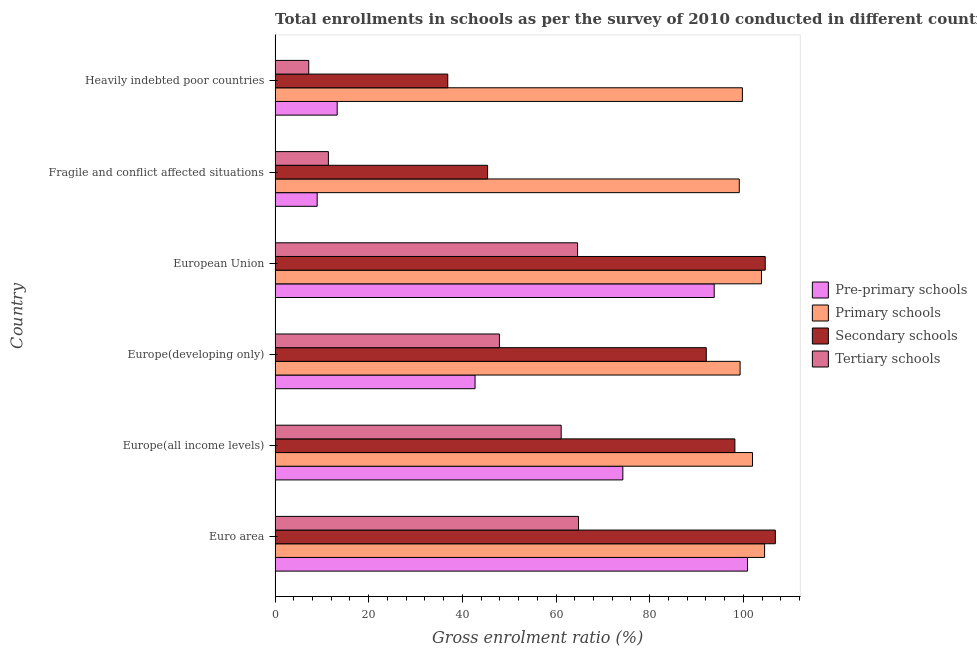How many groups of bars are there?
Your response must be concise. 6. What is the label of the 4th group of bars from the top?
Offer a very short reply. Europe(developing only). What is the gross enrolment ratio in pre-primary schools in European Union?
Make the answer very short. 93.79. Across all countries, what is the maximum gross enrolment ratio in secondary schools?
Provide a succinct answer. 106.85. Across all countries, what is the minimum gross enrolment ratio in pre-primary schools?
Offer a very short reply. 8.99. In which country was the gross enrolment ratio in tertiary schools maximum?
Provide a short and direct response. Euro area. In which country was the gross enrolment ratio in pre-primary schools minimum?
Your response must be concise. Fragile and conflict affected situations. What is the total gross enrolment ratio in primary schools in the graph?
Make the answer very short. 608.69. What is the difference between the gross enrolment ratio in pre-primary schools in Europe(all income levels) and that in European Union?
Make the answer very short. -19.51. What is the difference between the gross enrolment ratio in tertiary schools in Europe(all income levels) and the gross enrolment ratio in secondary schools in European Union?
Ensure brevity in your answer.  -43.58. What is the average gross enrolment ratio in tertiary schools per country?
Your answer should be compact. 42.84. What is the difference between the gross enrolment ratio in secondary schools and gross enrolment ratio in primary schools in European Union?
Keep it short and to the point. 0.8. In how many countries, is the gross enrolment ratio in secondary schools greater than 80 %?
Your answer should be very brief. 4. What is the ratio of the gross enrolment ratio in secondary schools in Europe(all income levels) to that in Fragile and conflict affected situations?
Offer a very short reply. 2.16. What is the difference between the highest and the second highest gross enrolment ratio in pre-primary schools?
Give a very brief answer. 7.12. What is the difference between the highest and the lowest gross enrolment ratio in tertiary schools?
Keep it short and to the point. 57.61. In how many countries, is the gross enrolment ratio in primary schools greater than the average gross enrolment ratio in primary schools taken over all countries?
Your answer should be compact. 3. Is the sum of the gross enrolment ratio in primary schools in Europe(developing only) and Fragile and conflict affected situations greater than the maximum gross enrolment ratio in secondary schools across all countries?
Offer a terse response. Yes. Is it the case that in every country, the sum of the gross enrolment ratio in pre-primary schools and gross enrolment ratio in secondary schools is greater than the sum of gross enrolment ratio in tertiary schools and gross enrolment ratio in primary schools?
Provide a short and direct response. No. What does the 1st bar from the top in Europe(all income levels) represents?
Your answer should be compact. Tertiary schools. What does the 3rd bar from the bottom in Europe(all income levels) represents?
Make the answer very short. Secondary schools. How many bars are there?
Give a very brief answer. 24. How many countries are there in the graph?
Your answer should be compact. 6. Does the graph contain any zero values?
Your answer should be compact. No. Does the graph contain grids?
Provide a short and direct response. No. How many legend labels are there?
Ensure brevity in your answer.  4. How are the legend labels stacked?
Ensure brevity in your answer.  Vertical. What is the title of the graph?
Give a very brief answer. Total enrollments in schools as per the survey of 2010 conducted in different countries. Does "Plant species" appear as one of the legend labels in the graph?
Provide a succinct answer. No. What is the label or title of the X-axis?
Your answer should be very brief. Gross enrolment ratio (%). What is the label or title of the Y-axis?
Provide a succinct answer. Country. What is the Gross enrolment ratio (%) in Pre-primary schools in Euro area?
Your answer should be very brief. 100.91. What is the Gross enrolment ratio (%) of Primary schools in Euro area?
Your answer should be compact. 104.55. What is the Gross enrolment ratio (%) in Secondary schools in Euro area?
Offer a very short reply. 106.85. What is the Gross enrolment ratio (%) of Tertiary schools in Euro area?
Keep it short and to the point. 64.81. What is the Gross enrolment ratio (%) in Pre-primary schools in Europe(all income levels)?
Your response must be concise. 74.28. What is the Gross enrolment ratio (%) of Primary schools in Europe(all income levels)?
Offer a terse response. 101.97. What is the Gross enrolment ratio (%) of Secondary schools in Europe(all income levels)?
Provide a succinct answer. 98.21. What is the Gross enrolment ratio (%) of Tertiary schools in Europe(all income levels)?
Provide a succinct answer. 61.11. What is the Gross enrolment ratio (%) of Pre-primary schools in Europe(developing only)?
Your answer should be compact. 42.71. What is the Gross enrolment ratio (%) of Primary schools in Europe(developing only)?
Offer a very short reply. 99.32. What is the Gross enrolment ratio (%) in Secondary schools in Europe(developing only)?
Your answer should be very brief. 92.1. What is the Gross enrolment ratio (%) of Tertiary schools in Europe(developing only)?
Offer a very short reply. 47.91. What is the Gross enrolment ratio (%) of Pre-primary schools in European Union?
Provide a short and direct response. 93.79. What is the Gross enrolment ratio (%) in Primary schools in European Union?
Your answer should be compact. 103.89. What is the Gross enrolment ratio (%) in Secondary schools in European Union?
Give a very brief answer. 104.69. What is the Gross enrolment ratio (%) of Tertiary schools in European Union?
Provide a short and direct response. 64.61. What is the Gross enrolment ratio (%) in Pre-primary schools in Fragile and conflict affected situations?
Offer a terse response. 8.99. What is the Gross enrolment ratio (%) in Primary schools in Fragile and conflict affected situations?
Provide a short and direct response. 99.14. What is the Gross enrolment ratio (%) in Secondary schools in Fragile and conflict affected situations?
Provide a succinct answer. 45.39. What is the Gross enrolment ratio (%) in Tertiary schools in Fragile and conflict affected situations?
Give a very brief answer. 11.39. What is the Gross enrolment ratio (%) of Pre-primary schools in Heavily indebted poor countries?
Offer a terse response. 13.27. What is the Gross enrolment ratio (%) of Primary schools in Heavily indebted poor countries?
Provide a succinct answer. 99.81. What is the Gross enrolment ratio (%) in Secondary schools in Heavily indebted poor countries?
Provide a short and direct response. 36.88. What is the Gross enrolment ratio (%) in Tertiary schools in Heavily indebted poor countries?
Your answer should be compact. 7.19. Across all countries, what is the maximum Gross enrolment ratio (%) of Pre-primary schools?
Offer a very short reply. 100.91. Across all countries, what is the maximum Gross enrolment ratio (%) of Primary schools?
Your answer should be compact. 104.55. Across all countries, what is the maximum Gross enrolment ratio (%) of Secondary schools?
Ensure brevity in your answer.  106.85. Across all countries, what is the maximum Gross enrolment ratio (%) of Tertiary schools?
Offer a very short reply. 64.81. Across all countries, what is the minimum Gross enrolment ratio (%) in Pre-primary schools?
Your answer should be very brief. 8.99. Across all countries, what is the minimum Gross enrolment ratio (%) of Primary schools?
Make the answer very short. 99.14. Across all countries, what is the minimum Gross enrolment ratio (%) of Secondary schools?
Provide a short and direct response. 36.88. Across all countries, what is the minimum Gross enrolment ratio (%) in Tertiary schools?
Your answer should be compact. 7.19. What is the total Gross enrolment ratio (%) of Pre-primary schools in the graph?
Keep it short and to the point. 333.94. What is the total Gross enrolment ratio (%) of Primary schools in the graph?
Ensure brevity in your answer.  608.69. What is the total Gross enrolment ratio (%) in Secondary schools in the graph?
Give a very brief answer. 484.12. What is the total Gross enrolment ratio (%) of Tertiary schools in the graph?
Provide a succinct answer. 257.01. What is the difference between the Gross enrolment ratio (%) in Pre-primary schools in Euro area and that in Europe(all income levels)?
Provide a succinct answer. 26.63. What is the difference between the Gross enrolment ratio (%) of Primary schools in Euro area and that in Europe(all income levels)?
Ensure brevity in your answer.  2.58. What is the difference between the Gross enrolment ratio (%) of Secondary schools in Euro area and that in Europe(all income levels)?
Your response must be concise. 8.64. What is the difference between the Gross enrolment ratio (%) of Tertiary schools in Euro area and that in Europe(all income levels)?
Make the answer very short. 3.7. What is the difference between the Gross enrolment ratio (%) in Pre-primary schools in Euro area and that in Europe(developing only)?
Give a very brief answer. 58.19. What is the difference between the Gross enrolment ratio (%) of Primary schools in Euro area and that in Europe(developing only)?
Your answer should be very brief. 5.23. What is the difference between the Gross enrolment ratio (%) of Secondary schools in Euro area and that in Europe(developing only)?
Make the answer very short. 14.75. What is the difference between the Gross enrolment ratio (%) in Tertiary schools in Euro area and that in Europe(developing only)?
Your answer should be compact. 16.89. What is the difference between the Gross enrolment ratio (%) of Pre-primary schools in Euro area and that in European Union?
Offer a very short reply. 7.12. What is the difference between the Gross enrolment ratio (%) in Primary schools in Euro area and that in European Union?
Offer a terse response. 0.66. What is the difference between the Gross enrolment ratio (%) of Secondary schools in Euro area and that in European Union?
Offer a terse response. 2.16. What is the difference between the Gross enrolment ratio (%) of Tertiary schools in Euro area and that in European Union?
Provide a succinct answer. 0.2. What is the difference between the Gross enrolment ratio (%) in Pre-primary schools in Euro area and that in Fragile and conflict affected situations?
Provide a succinct answer. 91.92. What is the difference between the Gross enrolment ratio (%) in Primary schools in Euro area and that in Fragile and conflict affected situations?
Your answer should be very brief. 5.41. What is the difference between the Gross enrolment ratio (%) in Secondary schools in Euro area and that in Fragile and conflict affected situations?
Offer a very short reply. 61.46. What is the difference between the Gross enrolment ratio (%) in Tertiary schools in Euro area and that in Fragile and conflict affected situations?
Offer a terse response. 53.42. What is the difference between the Gross enrolment ratio (%) of Pre-primary schools in Euro area and that in Heavily indebted poor countries?
Make the answer very short. 87.64. What is the difference between the Gross enrolment ratio (%) in Primary schools in Euro area and that in Heavily indebted poor countries?
Give a very brief answer. 4.74. What is the difference between the Gross enrolment ratio (%) of Secondary schools in Euro area and that in Heavily indebted poor countries?
Your response must be concise. 69.97. What is the difference between the Gross enrolment ratio (%) of Tertiary schools in Euro area and that in Heavily indebted poor countries?
Keep it short and to the point. 57.61. What is the difference between the Gross enrolment ratio (%) in Pre-primary schools in Europe(all income levels) and that in Europe(developing only)?
Provide a short and direct response. 31.56. What is the difference between the Gross enrolment ratio (%) in Primary schools in Europe(all income levels) and that in Europe(developing only)?
Offer a very short reply. 2.65. What is the difference between the Gross enrolment ratio (%) of Secondary schools in Europe(all income levels) and that in Europe(developing only)?
Your answer should be very brief. 6.11. What is the difference between the Gross enrolment ratio (%) of Tertiary schools in Europe(all income levels) and that in Europe(developing only)?
Your answer should be compact. 13.19. What is the difference between the Gross enrolment ratio (%) in Pre-primary schools in Europe(all income levels) and that in European Union?
Your response must be concise. -19.51. What is the difference between the Gross enrolment ratio (%) in Primary schools in Europe(all income levels) and that in European Union?
Offer a very short reply. -1.92. What is the difference between the Gross enrolment ratio (%) of Secondary schools in Europe(all income levels) and that in European Union?
Ensure brevity in your answer.  -6.48. What is the difference between the Gross enrolment ratio (%) in Tertiary schools in Europe(all income levels) and that in European Union?
Offer a very short reply. -3.5. What is the difference between the Gross enrolment ratio (%) of Pre-primary schools in Europe(all income levels) and that in Fragile and conflict affected situations?
Provide a succinct answer. 65.29. What is the difference between the Gross enrolment ratio (%) in Primary schools in Europe(all income levels) and that in Fragile and conflict affected situations?
Your response must be concise. 2.83. What is the difference between the Gross enrolment ratio (%) of Secondary schools in Europe(all income levels) and that in Fragile and conflict affected situations?
Provide a short and direct response. 52.82. What is the difference between the Gross enrolment ratio (%) of Tertiary schools in Europe(all income levels) and that in Fragile and conflict affected situations?
Your answer should be compact. 49.72. What is the difference between the Gross enrolment ratio (%) of Pre-primary schools in Europe(all income levels) and that in Heavily indebted poor countries?
Keep it short and to the point. 61.01. What is the difference between the Gross enrolment ratio (%) of Primary schools in Europe(all income levels) and that in Heavily indebted poor countries?
Your answer should be compact. 2.16. What is the difference between the Gross enrolment ratio (%) of Secondary schools in Europe(all income levels) and that in Heavily indebted poor countries?
Offer a very short reply. 61.33. What is the difference between the Gross enrolment ratio (%) of Tertiary schools in Europe(all income levels) and that in Heavily indebted poor countries?
Provide a short and direct response. 53.92. What is the difference between the Gross enrolment ratio (%) in Pre-primary schools in Europe(developing only) and that in European Union?
Give a very brief answer. -51.08. What is the difference between the Gross enrolment ratio (%) of Primary schools in Europe(developing only) and that in European Union?
Give a very brief answer. -4.57. What is the difference between the Gross enrolment ratio (%) of Secondary schools in Europe(developing only) and that in European Union?
Give a very brief answer. -12.59. What is the difference between the Gross enrolment ratio (%) in Tertiary schools in Europe(developing only) and that in European Union?
Provide a short and direct response. -16.69. What is the difference between the Gross enrolment ratio (%) of Pre-primary schools in Europe(developing only) and that in Fragile and conflict affected situations?
Offer a very short reply. 33.72. What is the difference between the Gross enrolment ratio (%) in Primary schools in Europe(developing only) and that in Fragile and conflict affected situations?
Ensure brevity in your answer.  0.18. What is the difference between the Gross enrolment ratio (%) of Secondary schools in Europe(developing only) and that in Fragile and conflict affected situations?
Offer a very short reply. 46.71. What is the difference between the Gross enrolment ratio (%) in Tertiary schools in Europe(developing only) and that in Fragile and conflict affected situations?
Your answer should be compact. 36.53. What is the difference between the Gross enrolment ratio (%) of Pre-primary schools in Europe(developing only) and that in Heavily indebted poor countries?
Offer a very short reply. 29.45. What is the difference between the Gross enrolment ratio (%) in Primary schools in Europe(developing only) and that in Heavily indebted poor countries?
Make the answer very short. -0.49. What is the difference between the Gross enrolment ratio (%) in Secondary schools in Europe(developing only) and that in Heavily indebted poor countries?
Your response must be concise. 55.22. What is the difference between the Gross enrolment ratio (%) in Tertiary schools in Europe(developing only) and that in Heavily indebted poor countries?
Offer a very short reply. 40.72. What is the difference between the Gross enrolment ratio (%) of Pre-primary schools in European Union and that in Fragile and conflict affected situations?
Provide a succinct answer. 84.8. What is the difference between the Gross enrolment ratio (%) of Primary schools in European Union and that in Fragile and conflict affected situations?
Ensure brevity in your answer.  4.75. What is the difference between the Gross enrolment ratio (%) of Secondary schools in European Union and that in Fragile and conflict affected situations?
Keep it short and to the point. 59.3. What is the difference between the Gross enrolment ratio (%) in Tertiary schools in European Union and that in Fragile and conflict affected situations?
Your answer should be very brief. 53.22. What is the difference between the Gross enrolment ratio (%) in Pre-primary schools in European Union and that in Heavily indebted poor countries?
Provide a short and direct response. 80.52. What is the difference between the Gross enrolment ratio (%) in Primary schools in European Union and that in Heavily indebted poor countries?
Your response must be concise. 4.08. What is the difference between the Gross enrolment ratio (%) in Secondary schools in European Union and that in Heavily indebted poor countries?
Provide a short and direct response. 67.81. What is the difference between the Gross enrolment ratio (%) in Tertiary schools in European Union and that in Heavily indebted poor countries?
Keep it short and to the point. 57.42. What is the difference between the Gross enrolment ratio (%) in Pre-primary schools in Fragile and conflict affected situations and that in Heavily indebted poor countries?
Your answer should be very brief. -4.28. What is the difference between the Gross enrolment ratio (%) of Primary schools in Fragile and conflict affected situations and that in Heavily indebted poor countries?
Ensure brevity in your answer.  -0.67. What is the difference between the Gross enrolment ratio (%) in Secondary schools in Fragile and conflict affected situations and that in Heavily indebted poor countries?
Your answer should be very brief. 8.51. What is the difference between the Gross enrolment ratio (%) in Tertiary schools in Fragile and conflict affected situations and that in Heavily indebted poor countries?
Offer a very short reply. 4.19. What is the difference between the Gross enrolment ratio (%) in Pre-primary schools in Euro area and the Gross enrolment ratio (%) in Primary schools in Europe(all income levels)?
Offer a terse response. -1.06. What is the difference between the Gross enrolment ratio (%) in Pre-primary schools in Euro area and the Gross enrolment ratio (%) in Secondary schools in Europe(all income levels)?
Ensure brevity in your answer.  2.7. What is the difference between the Gross enrolment ratio (%) of Pre-primary schools in Euro area and the Gross enrolment ratio (%) of Tertiary schools in Europe(all income levels)?
Give a very brief answer. 39.8. What is the difference between the Gross enrolment ratio (%) of Primary schools in Euro area and the Gross enrolment ratio (%) of Secondary schools in Europe(all income levels)?
Keep it short and to the point. 6.34. What is the difference between the Gross enrolment ratio (%) in Primary schools in Euro area and the Gross enrolment ratio (%) in Tertiary schools in Europe(all income levels)?
Provide a succinct answer. 43.45. What is the difference between the Gross enrolment ratio (%) of Secondary schools in Euro area and the Gross enrolment ratio (%) of Tertiary schools in Europe(all income levels)?
Offer a very short reply. 45.74. What is the difference between the Gross enrolment ratio (%) in Pre-primary schools in Euro area and the Gross enrolment ratio (%) in Primary schools in Europe(developing only)?
Your response must be concise. 1.59. What is the difference between the Gross enrolment ratio (%) in Pre-primary schools in Euro area and the Gross enrolment ratio (%) in Secondary schools in Europe(developing only)?
Offer a terse response. 8.81. What is the difference between the Gross enrolment ratio (%) of Pre-primary schools in Euro area and the Gross enrolment ratio (%) of Tertiary schools in Europe(developing only)?
Ensure brevity in your answer.  52.99. What is the difference between the Gross enrolment ratio (%) in Primary schools in Euro area and the Gross enrolment ratio (%) in Secondary schools in Europe(developing only)?
Your answer should be compact. 12.45. What is the difference between the Gross enrolment ratio (%) in Primary schools in Euro area and the Gross enrolment ratio (%) in Tertiary schools in Europe(developing only)?
Your answer should be compact. 56.64. What is the difference between the Gross enrolment ratio (%) of Secondary schools in Euro area and the Gross enrolment ratio (%) of Tertiary schools in Europe(developing only)?
Provide a short and direct response. 58.93. What is the difference between the Gross enrolment ratio (%) in Pre-primary schools in Euro area and the Gross enrolment ratio (%) in Primary schools in European Union?
Offer a very short reply. -2.98. What is the difference between the Gross enrolment ratio (%) in Pre-primary schools in Euro area and the Gross enrolment ratio (%) in Secondary schools in European Union?
Make the answer very short. -3.78. What is the difference between the Gross enrolment ratio (%) in Pre-primary schools in Euro area and the Gross enrolment ratio (%) in Tertiary schools in European Union?
Offer a terse response. 36.3. What is the difference between the Gross enrolment ratio (%) of Primary schools in Euro area and the Gross enrolment ratio (%) of Secondary schools in European Union?
Make the answer very short. -0.14. What is the difference between the Gross enrolment ratio (%) of Primary schools in Euro area and the Gross enrolment ratio (%) of Tertiary schools in European Union?
Your response must be concise. 39.95. What is the difference between the Gross enrolment ratio (%) in Secondary schools in Euro area and the Gross enrolment ratio (%) in Tertiary schools in European Union?
Your answer should be compact. 42.24. What is the difference between the Gross enrolment ratio (%) in Pre-primary schools in Euro area and the Gross enrolment ratio (%) in Primary schools in Fragile and conflict affected situations?
Keep it short and to the point. 1.76. What is the difference between the Gross enrolment ratio (%) in Pre-primary schools in Euro area and the Gross enrolment ratio (%) in Secondary schools in Fragile and conflict affected situations?
Offer a terse response. 55.52. What is the difference between the Gross enrolment ratio (%) of Pre-primary schools in Euro area and the Gross enrolment ratio (%) of Tertiary schools in Fragile and conflict affected situations?
Your answer should be compact. 89.52. What is the difference between the Gross enrolment ratio (%) of Primary schools in Euro area and the Gross enrolment ratio (%) of Secondary schools in Fragile and conflict affected situations?
Keep it short and to the point. 59.16. What is the difference between the Gross enrolment ratio (%) of Primary schools in Euro area and the Gross enrolment ratio (%) of Tertiary schools in Fragile and conflict affected situations?
Your answer should be compact. 93.17. What is the difference between the Gross enrolment ratio (%) in Secondary schools in Euro area and the Gross enrolment ratio (%) in Tertiary schools in Fragile and conflict affected situations?
Your answer should be compact. 95.46. What is the difference between the Gross enrolment ratio (%) in Pre-primary schools in Euro area and the Gross enrolment ratio (%) in Primary schools in Heavily indebted poor countries?
Ensure brevity in your answer.  1.1. What is the difference between the Gross enrolment ratio (%) of Pre-primary schools in Euro area and the Gross enrolment ratio (%) of Secondary schools in Heavily indebted poor countries?
Provide a succinct answer. 64.02. What is the difference between the Gross enrolment ratio (%) in Pre-primary schools in Euro area and the Gross enrolment ratio (%) in Tertiary schools in Heavily indebted poor countries?
Keep it short and to the point. 93.72. What is the difference between the Gross enrolment ratio (%) in Primary schools in Euro area and the Gross enrolment ratio (%) in Secondary schools in Heavily indebted poor countries?
Make the answer very short. 67.67. What is the difference between the Gross enrolment ratio (%) of Primary schools in Euro area and the Gross enrolment ratio (%) of Tertiary schools in Heavily indebted poor countries?
Offer a terse response. 97.36. What is the difference between the Gross enrolment ratio (%) in Secondary schools in Euro area and the Gross enrolment ratio (%) in Tertiary schools in Heavily indebted poor countries?
Ensure brevity in your answer.  99.66. What is the difference between the Gross enrolment ratio (%) in Pre-primary schools in Europe(all income levels) and the Gross enrolment ratio (%) in Primary schools in Europe(developing only)?
Provide a succinct answer. -25.04. What is the difference between the Gross enrolment ratio (%) of Pre-primary schools in Europe(all income levels) and the Gross enrolment ratio (%) of Secondary schools in Europe(developing only)?
Give a very brief answer. -17.82. What is the difference between the Gross enrolment ratio (%) of Pre-primary schools in Europe(all income levels) and the Gross enrolment ratio (%) of Tertiary schools in Europe(developing only)?
Keep it short and to the point. 26.36. What is the difference between the Gross enrolment ratio (%) of Primary schools in Europe(all income levels) and the Gross enrolment ratio (%) of Secondary schools in Europe(developing only)?
Offer a terse response. 9.87. What is the difference between the Gross enrolment ratio (%) of Primary schools in Europe(all income levels) and the Gross enrolment ratio (%) of Tertiary schools in Europe(developing only)?
Your response must be concise. 54.06. What is the difference between the Gross enrolment ratio (%) in Secondary schools in Europe(all income levels) and the Gross enrolment ratio (%) in Tertiary schools in Europe(developing only)?
Provide a short and direct response. 50.3. What is the difference between the Gross enrolment ratio (%) of Pre-primary schools in Europe(all income levels) and the Gross enrolment ratio (%) of Primary schools in European Union?
Your response must be concise. -29.61. What is the difference between the Gross enrolment ratio (%) in Pre-primary schools in Europe(all income levels) and the Gross enrolment ratio (%) in Secondary schools in European Union?
Offer a terse response. -30.41. What is the difference between the Gross enrolment ratio (%) of Pre-primary schools in Europe(all income levels) and the Gross enrolment ratio (%) of Tertiary schools in European Union?
Give a very brief answer. 9.67. What is the difference between the Gross enrolment ratio (%) of Primary schools in Europe(all income levels) and the Gross enrolment ratio (%) of Secondary schools in European Union?
Provide a succinct answer. -2.72. What is the difference between the Gross enrolment ratio (%) of Primary schools in Europe(all income levels) and the Gross enrolment ratio (%) of Tertiary schools in European Union?
Keep it short and to the point. 37.36. What is the difference between the Gross enrolment ratio (%) of Secondary schools in Europe(all income levels) and the Gross enrolment ratio (%) of Tertiary schools in European Union?
Give a very brief answer. 33.6. What is the difference between the Gross enrolment ratio (%) in Pre-primary schools in Europe(all income levels) and the Gross enrolment ratio (%) in Primary schools in Fragile and conflict affected situations?
Ensure brevity in your answer.  -24.87. What is the difference between the Gross enrolment ratio (%) in Pre-primary schools in Europe(all income levels) and the Gross enrolment ratio (%) in Secondary schools in Fragile and conflict affected situations?
Make the answer very short. 28.89. What is the difference between the Gross enrolment ratio (%) in Pre-primary schools in Europe(all income levels) and the Gross enrolment ratio (%) in Tertiary schools in Fragile and conflict affected situations?
Your response must be concise. 62.89. What is the difference between the Gross enrolment ratio (%) of Primary schools in Europe(all income levels) and the Gross enrolment ratio (%) of Secondary schools in Fragile and conflict affected situations?
Keep it short and to the point. 56.58. What is the difference between the Gross enrolment ratio (%) in Primary schools in Europe(all income levels) and the Gross enrolment ratio (%) in Tertiary schools in Fragile and conflict affected situations?
Your response must be concise. 90.58. What is the difference between the Gross enrolment ratio (%) of Secondary schools in Europe(all income levels) and the Gross enrolment ratio (%) of Tertiary schools in Fragile and conflict affected situations?
Offer a very short reply. 86.82. What is the difference between the Gross enrolment ratio (%) of Pre-primary schools in Europe(all income levels) and the Gross enrolment ratio (%) of Primary schools in Heavily indebted poor countries?
Provide a succinct answer. -25.53. What is the difference between the Gross enrolment ratio (%) of Pre-primary schools in Europe(all income levels) and the Gross enrolment ratio (%) of Secondary schools in Heavily indebted poor countries?
Offer a terse response. 37.39. What is the difference between the Gross enrolment ratio (%) in Pre-primary schools in Europe(all income levels) and the Gross enrolment ratio (%) in Tertiary schools in Heavily indebted poor countries?
Give a very brief answer. 67.08. What is the difference between the Gross enrolment ratio (%) of Primary schools in Europe(all income levels) and the Gross enrolment ratio (%) of Secondary schools in Heavily indebted poor countries?
Your response must be concise. 65.09. What is the difference between the Gross enrolment ratio (%) in Primary schools in Europe(all income levels) and the Gross enrolment ratio (%) in Tertiary schools in Heavily indebted poor countries?
Keep it short and to the point. 94.78. What is the difference between the Gross enrolment ratio (%) in Secondary schools in Europe(all income levels) and the Gross enrolment ratio (%) in Tertiary schools in Heavily indebted poor countries?
Give a very brief answer. 91.02. What is the difference between the Gross enrolment ratio (%) in Pre-primary schools in Europe(developing only) and the Gross enrolment ratio (%) in Primary schools in European Union?
Keep it short and to the point. -61.18. What is the difference between the Gross enrolment ratio (%) in Pre-primary schools in Europe(developing only) and the Gross enrolment ratio (%) in Secondary schools in European Union?
Make the answer very short. -61.98. What is the difference between the Gross enrolment ratio (%) of Pre-primary schools in Europe(developing only) and the Gross enrolment ratio (%) of Tertiary schools in European Union?
Ensure brevity in your answer.  -21.89. What is the difference between the Gross enrolment ratio (%) in Primary schools in Europe(developing only) and the Gross enrolment ratio (%) in Secondary schools in European Union?
Offer a very short reply. -5.37. What is the difference between the Gross enrolment ratio (%) of Primary schools in Europe(developing only) and the Gross enrolment ratio (%) of Tertiary schools in European Union?
Your answer should be compact. 34.71. What is the difference between the Gross enrolment ratio (%) in Secondary schools in Europe(developing only) and the Gross enrolment ratio (%) in Tertiary schools in European Union?
Make the answer very short. 27.49. What is the difference between the Gross enrolment ratio (%) of Pre-primary schools in Europe(developing only) and the Gross enrolment ratio (%) of Primary schools in Fragile and conflict affected situations?
Provide a short and direct response. -56.43. What is the difference between the Gross enrolment ratio (%) in Pre-primary schools in Europe(developing only) and the Gross enrolment ratio (%) in Secondary schools in Fragile and conflict affected situations?
Provide a succinct answer. -2.68. What is the difference between the Gross enrolment ratio (%) of Pre-primary schools in Europe(developing only) and the Gross enrolment ratio (%) of Tertiary schools in Fragile and conflict affected situations?
Offer a terse response. 31.33. What is the difference between the Gross enrolment ratio (%) in Primary schools in Europe(developing only) and the Gross enrolment ratio (%) in Secondary schools in Fragile and conflict affected situations?
Ensure brevity in your answer.  53.93. What is the difference between the Gross enrolment ratio (%) in Primary schools in Europe(developing only) and the Gross enrolment ratio (%) in Tertiary schools in Fragile and conflict affected situations?
Keep it short and to the point. 87.93. What is the difference between the Gross enrolment ratio (%) in Secondary schools in Europe(developing only) and the Gross enrolment ratio (%) in Tertiary schools in Fragile and conflict affected situations?
Make the answer very short. 80.71. What is the difference between the Gross enrolment ratio (%) of Pre-primary schools in Europe(developing only) and the Gross enrolment ratio (%) of Primary schools in Heavily indebted poor countries?
Make the answer very short. -57.1. What is the difference between the Gross enrolment ratio (%) in Pre-primary schools in Europe(developing only) and the Gross enrolment ratio (%) in Secondary schools in Heavily indebted poor countries?
Keep it short and to the point. 5.83. What is the difference between the Gross enrolment ratio (%) of Pre-primary schools in Europe(developing only) and the Gross enrolment ratio (%) of Tertiary schools in Heavily indebted poor countries?
Offer a very short reply. 35.52. What is the difference between the Gross enrolment ratio (%) of Primary schools in Europe(developing only) and the Gross enrolment ratio (%) of Secondary schools in Heavily indebted poor countries?
Keep it short and to the point. 62.44. What is the difference between the Gross enrolment ratio (%) of Primary schools in Europe(developing only) and the Gross enrolment ratio (%) of Tertiary schools in Heavily indebted poor countries?
Your response must be concise. 92.13. What is the difference between the Gross enrolment ratio (%) in Secondary schools in Europe(developing only) and the Gross enrolment ratio (%) in Tertiary schools in Heavily indebted poor countries?
Provide a succinct answer. 84.91. What is the difference between the Gross enrolment ratio (%) in Pre-primary schools in European Union and the Gross enrolment ratio (%) in Primary schools in Fragile and conflict affected situations?
Offer a very short reply. -5.35. What is the difference between the Gross enrolment ratio (%) in Pre-primary schools in European Union and the Gross enrolment ratio (%) in Secondary schools in Fragile and conflict affected situations?
Give a very brief answer. 48.4. What is the difference between the Gross enrolment ratio (%) in Pre-primary schools in European Union and the Gross enrolment ratio (%) in Tertiary schools in Fragile and conflict affected situations?
Provide a succinct answer. 82.4. What is the difference between the Gross enrolment ratio (%) of Primary schools in European Union and the Gross enrolment ratio (%) of Secondary schools in Fragile and conflict affected situations?
Your response must be concise. 58.5. What is the difference between the Gross enrolment ratio (%) in Primary schools in European Union and the Gross enrolment ratio (%) in Tertiary schools in Fragile and conflict affected situations?
Keep it short and to the point. 92.5. What is the difference between the Gross enrolment ratio (%) of Secondary schools in European Union and the Gross enrolment ratio (%) of Tertiary schools in Fragile and conflict affected situations?
Your answer should be very brief. 93.3. What is the difference between the Gross enrolment ratio (%) in Pre-primary schools in European Union and the Gross enrolment ratio (%) in Primary schools in Heavily indebted poor countries?
Offer a terse response. -6.02. What is the difference between the Gross enrolment ratio (%) of Pre-primary schools in European Union and the Gross enrolment ratio (%) of Secondary schools in Heavily indebted poor countries?
Your answer should be compact. 56.91. What is the difference between the Gross enrolment ratio (%) in Pre-primary schools in European Union and the Gross enrolment ratio (%) in Tertiary schools in Heavily indebted poor countries?
Offer a terse response. 86.6. What is the difference between the Gross enrolment ratio (%) in Primary schools in European Union and the Gross enrolment ratio (%) in Secondary schools in Heavily indebted poor countries?
Your answer should be very brief. 67.01. What is the difference between the Gross enrolment ratio (%) in Primary schools in European Union and the Gross enrolment ratio (%) in Tertiary schools in Heavily indebted poor countries?
Offer a very short reply. 96.7. What is the difference between the Gross enrolment ratio (%) in Secondary schools in European Union and the Gross enrolment ratio (%) in Tertiary schools in Heavily indebted poor countries?
Offer a very short reply. 97.5. What is the difference between the Gross enrolment ratio (%) of Pre-primary schools in Fragile and conflict affected situations and the Gross enrolment ratio (%) of Primary schools in Heavily indebted poor countries?
Give a very brief answer. -90.82. What is the difference between the Gross enrolment ratio (%) of Pre-primary schools in Fragile and conflict affected situations and the Gross enrolment ratio (%) of Secondary schools in Heavily indebted poor countries?
Your answer should be compact. -27.89. What is the difference between the Gross enrolment ratio (%) of Pre-primary schools in Fragile and conflict affected situations and the Gross enrolment ratio (%) of Tertiary schools in Heavily indebted poor countries?
Your answer should be very brief. 1.8. What is the difference between the Gross enrolment ratio (%) in Primary schools in Fragile and conflict affected situations and the Gross enrolment ratio (%) in Secondary schools in Heavily indebted poor countries?
Your answer should be compact. 62.26. What is the difference between the Gross enrolment ratio (%) in Primary schools in Fragile and conflict affected situations and the Gross enrolment ratio (%) in Tertiary schools in Heavily indebted poor countries?
Keep it short and to the point. 91.95. What is the difference between the Gross enrolment ratio (%) of Secondary schools in Fragile and conflict affected situations and the Gross enrolment ratio (%) of Tertiary schools in Heavily indebted poor countries?
Keep it short and to the point. 38.2. What is the average Gross enrolment ratio (%) of Pre-primary schools per country?
Your answer should be compact. 55.66. What is the average Gross enrolment ratio (%) in Primary schools per country?
Provide a succinct answer. 101.45. What is the average Gross enrolment ratio (%) of Secondary schools per country?
Give a very brief answer. 80.69. What is the average Gross enrolment ratio (%) of Tertiary schools per country?
Your answer should be very brief. 42.84. What is the difference between the Gross enrolment ratio (%) of Pre-primary schools and Gross enrolment ratio (%) of Primary schools in Euro area?
Your answer should be compact. -3.65. What is the difference between the Gross enrolment ratio (%) of Pre-primary schools and Gross enrolment ratio (%) of Secondary schools in Euro area?
Ensure brevity in your answer.  -5.94. What is the difference between the Gross enrolment ratio (%) of Pre-primary schools and Gross enrolment ratio (%) of Tertiary schools in Euro area?
Provide a succinct answer. 36.1. What is the difference between the Gross enrolment ratio (%) of Primary schools and Gross enrolment ratio (%) of Secondary schools in Euro area?
Provide a succinct answer. -2.29. What is the difference between the Gross enrolment ratio (%) in Primary schools and Gross enrolment ratio (%) in Tertiary schools in Euro area?
Offer a very short reply. 39.75. What is the difference between the Gross enrolment ratio (%) of Secondary schools and Gross enrolment ratio (%) of Tertiary schools in Euro area?
Give a very brief answer. 42.04. What is the difference between the Gross enrolment ratio (%) of Pre-primary schools and Gross enrolment ratio (%) of Primary schools in Europe(all income levels)?
Give a very brief answer. -27.69. What is the difference between the Gross enrolment ratio (%) in Pre-primary schools and Gross enrolment ratio (%) in Secondary schools in Europe(all income levels)?
Your response must be concise. -23.93. What is the difference between the Gross enrolment ratio (%) of Pre-primary schools and Gross enrolment ratio (%) of Tertiary schools in Europe(all income levels)?
Provide a short and direct response. 13.17. What is the difference between the Gross enrolment ratio (%) in Primary schools and Gross enrolment ratio (%) in Secondary schools in Europe(all income levels)?
Offer a terse response. 3.76. What is the difference between the Gross enrolment ratio (%) in Primary schools and Gross enrolment ratio (%) in Tertiary schools in Europe(all income levels)?
Give a very brief answer. 40.86. What is the difference between the Gross enrolment ratio (%) in Secondary schools and Gross enrolment ratio (%) in Tertiary schools in Europe(all income levels)?
Offer a terse response. 37.1. What is the difference between the Gross enrolment ratio (%) in Pre-primary schools and Gross enrolment ratio (%) in Primary schools in Europe(developing only)?
Ensure brevity in your answer.  -56.61. What is the difference between the Gross enrolment ratio (%) in Pre-primary schools and Gross enrolment ratio (%) in Secondary schools in Europe(developing only)?
Provide a succinct answer. -49.39. What is the difference between the Gross enrolment ratio (%) of Pre-primary schools and Gross enrolment ratio (%) of Tertiary schools in Europe(developing only)?
Make the answer very short. -5.2. What is the difference between the Gross enrolment ratio (%) of Primary schools and Gross enrolment ratio (%) of Secondary schools in Europe(developing only)?
Your response must be concise. 7.22. What is the difference between the Gross enrolment ratio (%) of Primary schools and Gross enrolment ratio (%) of Tertiary schools in Europe(developing only)?
Your response must be concise. 51.4. What is the difference between the Gross enrolment ratio (%) in Secondary schools and Gross enrolment ratio (%) in Tertiary schools in Europe(developing only)?
Ensure brevity in your answer.  44.19. What is the difference between the Gross enrolment ratio (%) in Pre-primary schools and Gross enrolment ratio (%) in Primary schools in European Union?
Your answer should be very brief. -10.1. What is the difference between the Gross enrolment ratio (%) in Pre-primary schools and Gross enrolment ratio (%) in Secondary schools in European Union?
Your answer should be very brief. -10.9. What is the difference between the Gross enrolment ratio (%) of Pre-primary schools and Gross enrolment ratio (%) of Tertiary schools in European Union?
Provide a succinct answer. 29.18. What is the difference between the Gross enrolment ratio (%) in Primary schools and Gross enrolment ratio (%) in Secondary schools in European Union?
Offer a terse response. -0.8. What is the difference between the Gross enrolment ratio (%) in Primary schools and Gross enrolment ratio (%) in Tertiary schools in European Union?
Offer a very short reply. 39.28. What is the difference between the Gross enrolment ratio (%) in Secondary schools and Gross enrolment ratio (%) in Tertiary schools in European Union?
Your response must be concise. 40.08. What is the difference between the Gross enrolment ratio (%) of Pre-primary schools and Gross enrolment ratio (%) of Primary schools in Fragile and conflict affected situations?
Give a very brief answer. -90.15. What is the difference between the Gross enrolment ratio (%) in Pre-primary schools and Gross enrolment ratio (%) in Secondary schools in Fragile and conflict affected situations?
Give a very brief answer. -36.4. What is the difference between the Gross enrolment ratio (%) in Pre-primary schools and Gross enrolment ratio (%) in Tertiary schools in Fragile and conflict affected situations?
Provide a succinct answer. -2.4. What is the difference between the Gross enrolment ratio (%) of Primary schools and Gross enrolment ratio (%) of Secondary schools in Fragile and conflict affected situations?
Give a very brief answer. 53.75. What is the difference between the Gross enrolment ratio (%) in Primary schools and Gross enrolment ratio (%) in Tertiary schools in Fragile and conflict affected situations?
Your answer should be very brief. 87.76. What is the difference between the Gross enrolment ratio (%) in Secondary schools and Gross enrolment ratio (%) in Tertiary schools in Fragile and conflict affected situations?
Give a very brief answer. 34. What is the difference between the Gross enrolment ratio (%) in Pre-primary schools and Gross enrolment ratio (%) in Primary schools in Heavily indebted poor countries?
Your response must be concise. -86.54. What is the difference between the Gross enrolment ratio (%) in Pre-primary schools and Gross enrolment ratio (%) in Secondary schools in Heavily indebted poor countries?
Offer a very short reply. -23.62. What is the difference between the Gross enrolment ratio (%) in Pre-primary schools and Gross enrolment ratio (%) in Tertiary schools in Heavily indebted poor countries?
Ensure brevity in your answer.  6.07. What is the difference between the Gross enrolment ratio (%) in Primary schools and Gross enrolment ratio (%) in Secondary schools in Heavily indebted poor countries?
Offer a very short reply. 62.93. What is the difference between the Gross enrolment ratio (%) in Primary schools and Gross enrolment ratio (%) in Tertiary schools in Heavily indebted poor countries?
Keep it short and to the point. 92.62. What is the difference between the Gross enrolment ratio (%) in Secondary schools and Gross enrolment ratio (%) in Tertiary schools in Heavily indebted poor countries?
Make the answer very short. 29.69. What is the ratio of the Gross enrolment ratio (%) of Pre-primary schools in Euro area to that in Europe(all income levels)?
Give a very brief answer. 1.36. What is the ratio of the Gross enrolment ratio (%) of Primary schools in Euro area to that in Europe(all income levels)?
Offer a terse response. 1.03. What is the ratio of the Gross enrolment ratio (%) of Secondary schools in Euro area to that in Europe(all income levels)?
Ensure brevity in your answer.  1.09. What is the ratio of the Gross enrolment ratio (%) in Tertiary schools in Euro area to that in Europe(all income levels)?
Make the answer very short. 1.06. What is the ratio of the Gross enrolment ratio (%) of Pre-primary schools in Euro area to that in Europe(developing only)?
Your answer should be very brief. 2.36. What is the ratio of the Gross enrolment ratio (%) in Primary schools in Euro area to that in Europe(developing only)?
Provide a succinct answer. 1.05. What is the ratio of the Gross enrolment ratio (%) of Secondary schools in Euro area to that in Europe(developing only)?
Give a very brief answer. 1.16. What is the ratio of the Gross enrolment ratio (%) in Tertiary schools in Euro area to that in Europe(developing only)?
Provide a succinct answer. 1.35. What is the ratio of the Gross enrolment ratio (%) of Pre-primary schools in Euro area to that in European Union?
Provide a short and direct response. 1.08. What is the ratio of the Gross enrolment ratio (%) of Primary schools in Euro area to that in European Union?
Keep it short and to the point. 1.01. What is the ratio of the Gross enrolment ratio (%) of Secondary schools in Euro area to that in European Union?
Provide a short and direct response. 1.02. What is the ratio of the Gross enrolment ratio (%) of Pre-primary schools in Euro area to that in Fragile and conflict affected situations?
Keep it short and to the point. 11.22. What is the ratio of the Gross enrolment ratio (%) of Primary schools in Euro area to that in Fragile and conflict affected situations?
Give a very brief answer. 1.05. What is the ratio of the Gross enrolment ratio (%) in Secondary schools in Euro area to that in Fragile and conflict affected situations?
Make the answer very short. 2.35. What is the ratio of the Gross enrolment ratio (%) in Tertiary schools in Euro area to that in Fragile and conflict affected situations?
Ensure brevity in your answer.  5.69. What is the ratio of the Gross enrolment ratio (%) in Pre-primary schools in Euro area to that in Heavily indebted poor countries?
Give a very brief answer. 7.61. What is the ratio of the Gross enrolment ratio (%) in Primary schools in Euro area to that in Heavily indebted poor countries?
Provide a short and direct response. 1.05. What is the ratio of the Gross enrolment ratio (%) in Secondary schools in Euro area to that in Heavily indebted poor countries?
Your answer should be very brief. 2.9. What is the ratio of the Gross enrolment ratio (%) of Tertiary schools in Euro area to that in Heavily indebted poor countries?
Your answer should be compact. 9.01. What is the ratio of the Gross enrolment ratio (%) in Pre-primary schools in Europe(all income levels) to that in Europe(developing only)?
Provide a succinct answer. 1.74. What is the ratio of the Gross enrolment ratio (%) in Primary schools in Europe(all income levels) to that in Europe(developing only)?
Make the answer very short. 1.03. What is the ratio of the Gross enrolment ratio (%) in Secondary schools in Europe(all income levels) to that in Europe(developing only)?
Provide a succinct answer. 1.07. What is the ratio of the Gross enrolment ratio (%) in Tertiary schools in Europe(all income levels) to that in Europe(developing only)?
Make the answer very short. 1.28. What is the ratio of the Gross enrolment ratio (%) in Pre-primary schools in Europe(all income levels) to that in European Union?
Provide a succinct answer. 0.79. What is the ratio of the Gross enrolment ratio (%) of Primary schools in Europe(all income levels) to that in European Union?
Your answer should be very brief. 0.98. What is the ratio of the Gross enrolment ratio (%) in Secondary schools in Europe(all income levels) to that in European Union?
Keep it short and to the point. 0.94. What is the ratio of the Gross enrolment ratio (%) in Tertiary schools in Europe(all income levels) to that in European Union?
Give a very brief answer. 0.95. What is the ratio of the Gross enrolment ratio (%) of Pre-primary schools in Europe(all income levels) to that in Fragile and conflict affected situations?
Offer a terse response. 8.26. What is the ratio of the Gross enrolment ratio (%) in Primary schools in Europe(all income levels) to that in Fragile and conflict affected situations?
Provide a succinct answer. 1.03. What is the ratio of the Gross enrolment ratio (%) of Secondary schools in Europe(all income levels) to that in Fragile and conflict affected situations?
Keep it short and to the point. 2.16. What is the ratio of the Gross enrolment ratio (%) of Tertiary schools in Europe(all income levels) to that in Fragile and conflict affected situations?
Give a very brief answer. 5.37. What is the ratio of the Gross enrolment ratio (%) of Pre-primary schools in Europe(all income levels) to that in Heavily indebted poor countries?
Give a very brief answer. 5.6. What is the ratio of the Gross enrolment ratio (%) in Primary schools in Europe(all income levels) to that in Heavily indebted poor countries?
Offer a very short reply. 1.02. What is the ratio of the Gross enrolment ratio (%) of Secondary schools in Europe(all income levels) to that in Heavily indebted poor countries?
Your response must be concise. 2.66. What is the ratio of the Gross enrolment ratio (%) in Tertiary schools in Europe(all income levels) to that in Heavily indebted poor countries?
Your response must be concise. 8.5. What is the ratio of the Gross enrolment ratio (%) of Pre-primary schools in Europe(developing only) to that in European Union?
Offer a terse response. 0.46. What is the ratio of the Gross enrolment ratio (%) in Primary schools in Europe(developing only) to that in European Union?
Give a very brief answer. 0.96. What is the ratio of the Gross enrolment ratio (%) of Secondary schools in Europe(developing only) to that in European Union?
Your response must be concise. 0.88. What is the ratio of the Gross enrolment ratio (%) in Tertiary schools in Europe(developing only) to that in European Union?
Offer a very short reply. 0.74. What is the ratio of the Gross enrolment ratio (%) of Pre-primary schools in Europe(developing only) to that in Fragile and conflict affected situations?
Provide a short and direct response. 4.75. What is the ratio of the Gross enrolment ratio (%) of Primary schools in Europe(developing only) to that in Fragile and conflict affected situations?
Keep it short and to the point. 1. What is the ratio of the Gross enrolment ratio (%) of Secondary schools in Europe(developing only) to that in Fragile and conflict affected situations?
Ensure brevity in your answer.  2.03. What is the ratio of the Gross enrolment ratio (%) in Tertiary schools in Europe(developing only) to that in Fragile and conflict affected situations?
Offer a very short reply. 4.21. What is the ratio of the Gross enrolment ratio (%) of Pre-primary schools in Europe(developing only) to that in Heavily indebted poor countries?
Your response must be concise. 3.22. What is the ratio of the Gross enrolment ratio (%) of Secondary schools in Europe(developing only) to that in Heavily indebted poor countries?
Make the answer very short. 2.5. What is the ratio of the Gross enrolment ratio (%) in Tertiary schools in Europe(developing only) to that in Heavily indebted poor countries?
Provide a succinct answer. 6.66. What is the ratio of the Gross enrolment ratio (%) of Pre-primary schools in European Union to that in Fragile and conflict affected situations?
Provide a succinct answer. 10.43. What is the ratio of the Gross enrolment ratio (%) in Primary schools in European Union to that in Fragile and conflict affected situations?
Your response must be concise. 1.05. What is the ratio of the Gross enrolment ratio (%) in Secondary schools in European Union to that in Fragile and conflict affected situations?
Give a very brief answer. 2.31. What is the ratio of the Gross enrolment ratio (%) of Tertiary schools in European Union to that in Fragile and conflict affected situations?
Keep it short and to the point. 5.67. What is the ratio of the Gross enrolment ratio (%) in Pre-primary schools in European Union to that in Heavily indebted poor countries?
Keep it short and to the point. 7.07. What is the ratio of the Gross enrolment ratio (%) in Primary schools in European Union to that in Heavily indebted poor countries?
Your answer should be compact. 1.04. What is the ratio of the Gross enrolment ratio (%) of Secondary schools in European Union to that in Heavily indebted poor countries?
Your answer should be compact. 2.84. What is the ratio of the Gross enrolment ratio (%) of Tertiary schools in European Union to that in Heavily indebted poor countries?
Your answer should be compact. 8.98. What is the ratio of the Gross enrolment ratio (%) of Pre-primary schools in Fragile and conflict affected situations to that in Heavily indebted poor countries?
Give a very brief answer. 0.68. What is the ratio of the Gross enrolment ratio (%) of Primary schools in Fragile and conflict affected situations to that in Heavily indebted poor countries?
Offer a terse response. 0.99. What is the ratio of the Gross enrolment ratio (%) in Secondary schools in Fragile and conflict affected situations to that in Heavily indebted poor countries?
Keep it short and to the point. 1.23. What is the ratio of the Gross enrolment ratio (%) in Tertiary schools in Fragile and conflict affected situations to that in Heavily indebted poor countries?
Offer a very short reply. 1.58. What is the difference between the highest and the second highest Gross enrolment ratio (%) of Pre-primary schools?
Give a very brief answer. 7.12. What is the difference between the highest and the second highest Gross enrolment ratio (%) of Primary schools?
Your response must be concise. 0.66. What is the difference between the highest and the second highest Gross enrolment ratio (%) in Secondary schools?
Your answer should be very brief. 2.16. What is the difference between the highest and the second highest Gross enrolment ratio (%) in Tertiary schools?
Offer a very short reply. 0.2. What is the difference between the highest and the lowest Gross enrolment ratio (%) in Pre-primary schools?
Offer a terse response. 91.92. What is the difference between the highest and the lowest Gross enrolment ratio (%) in Primary schools?
Ensure brevity in your answer.  5.41. What is the difference between the highest and the lowest Gross enrolment ratio (%) in Secondary schools?
Ensure brevity in your answer.  69.97. What is the difference between the highest and the lowest Gross enrolment ratio (%) in Tertiary schools?
Keep it short and to the point. 57.61. 